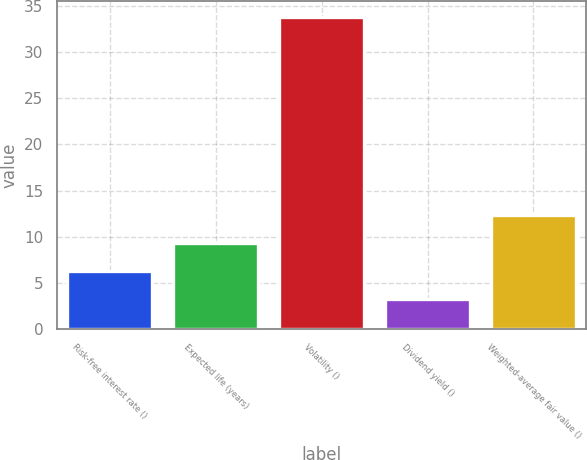Convert chart. <chart><loc_0><loc_0><loc_500><loc_500><bar_chart><fcel>Risk-free interest rate ()<fcel>Expected life (years)<fcel>Volatility ()<fcel>Dividend yield ()<fcel>Weighted-average fair value ()<nl><fcel>6.3<fcel>9.36<fcel>33.8<fcel>3.24<fcel>12.42<nl></chart> 